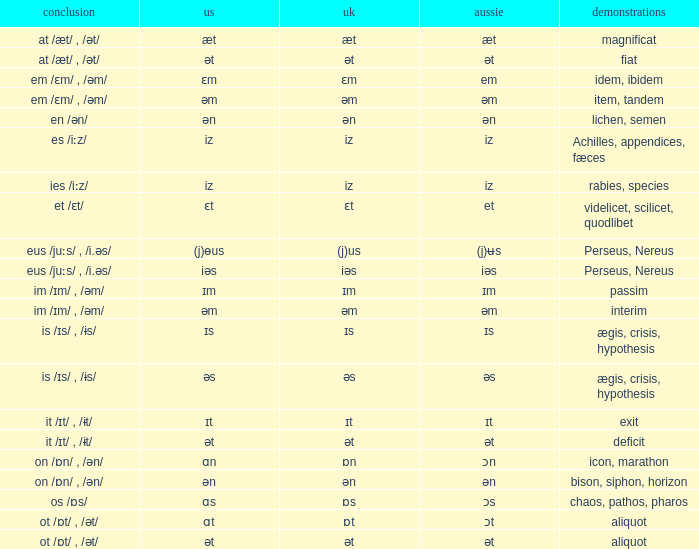Which Ending has British of iz, and Examples of achilles, appendices, fæces? Es /iːz/. 